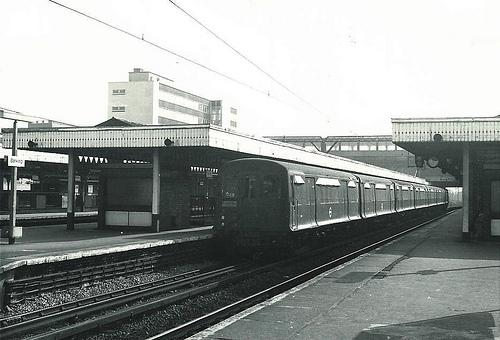Question: what color is the roof of the station?
Choices:
A. Brown.
B. White.
C. Red.
D. Black.
Answer with the letter. Answer: B Question: how many poles are visible under the roofs?
Choices:
A. Four.
B. Five.
C. Two.
D. Three.
Answer with the letter. Answer: D Question: what is on the ground under the tracks?
Choices:
A. Roadkill.
B. Ice.
C. Gravel.
D. Water.
Answer with the letter. Answer: C 